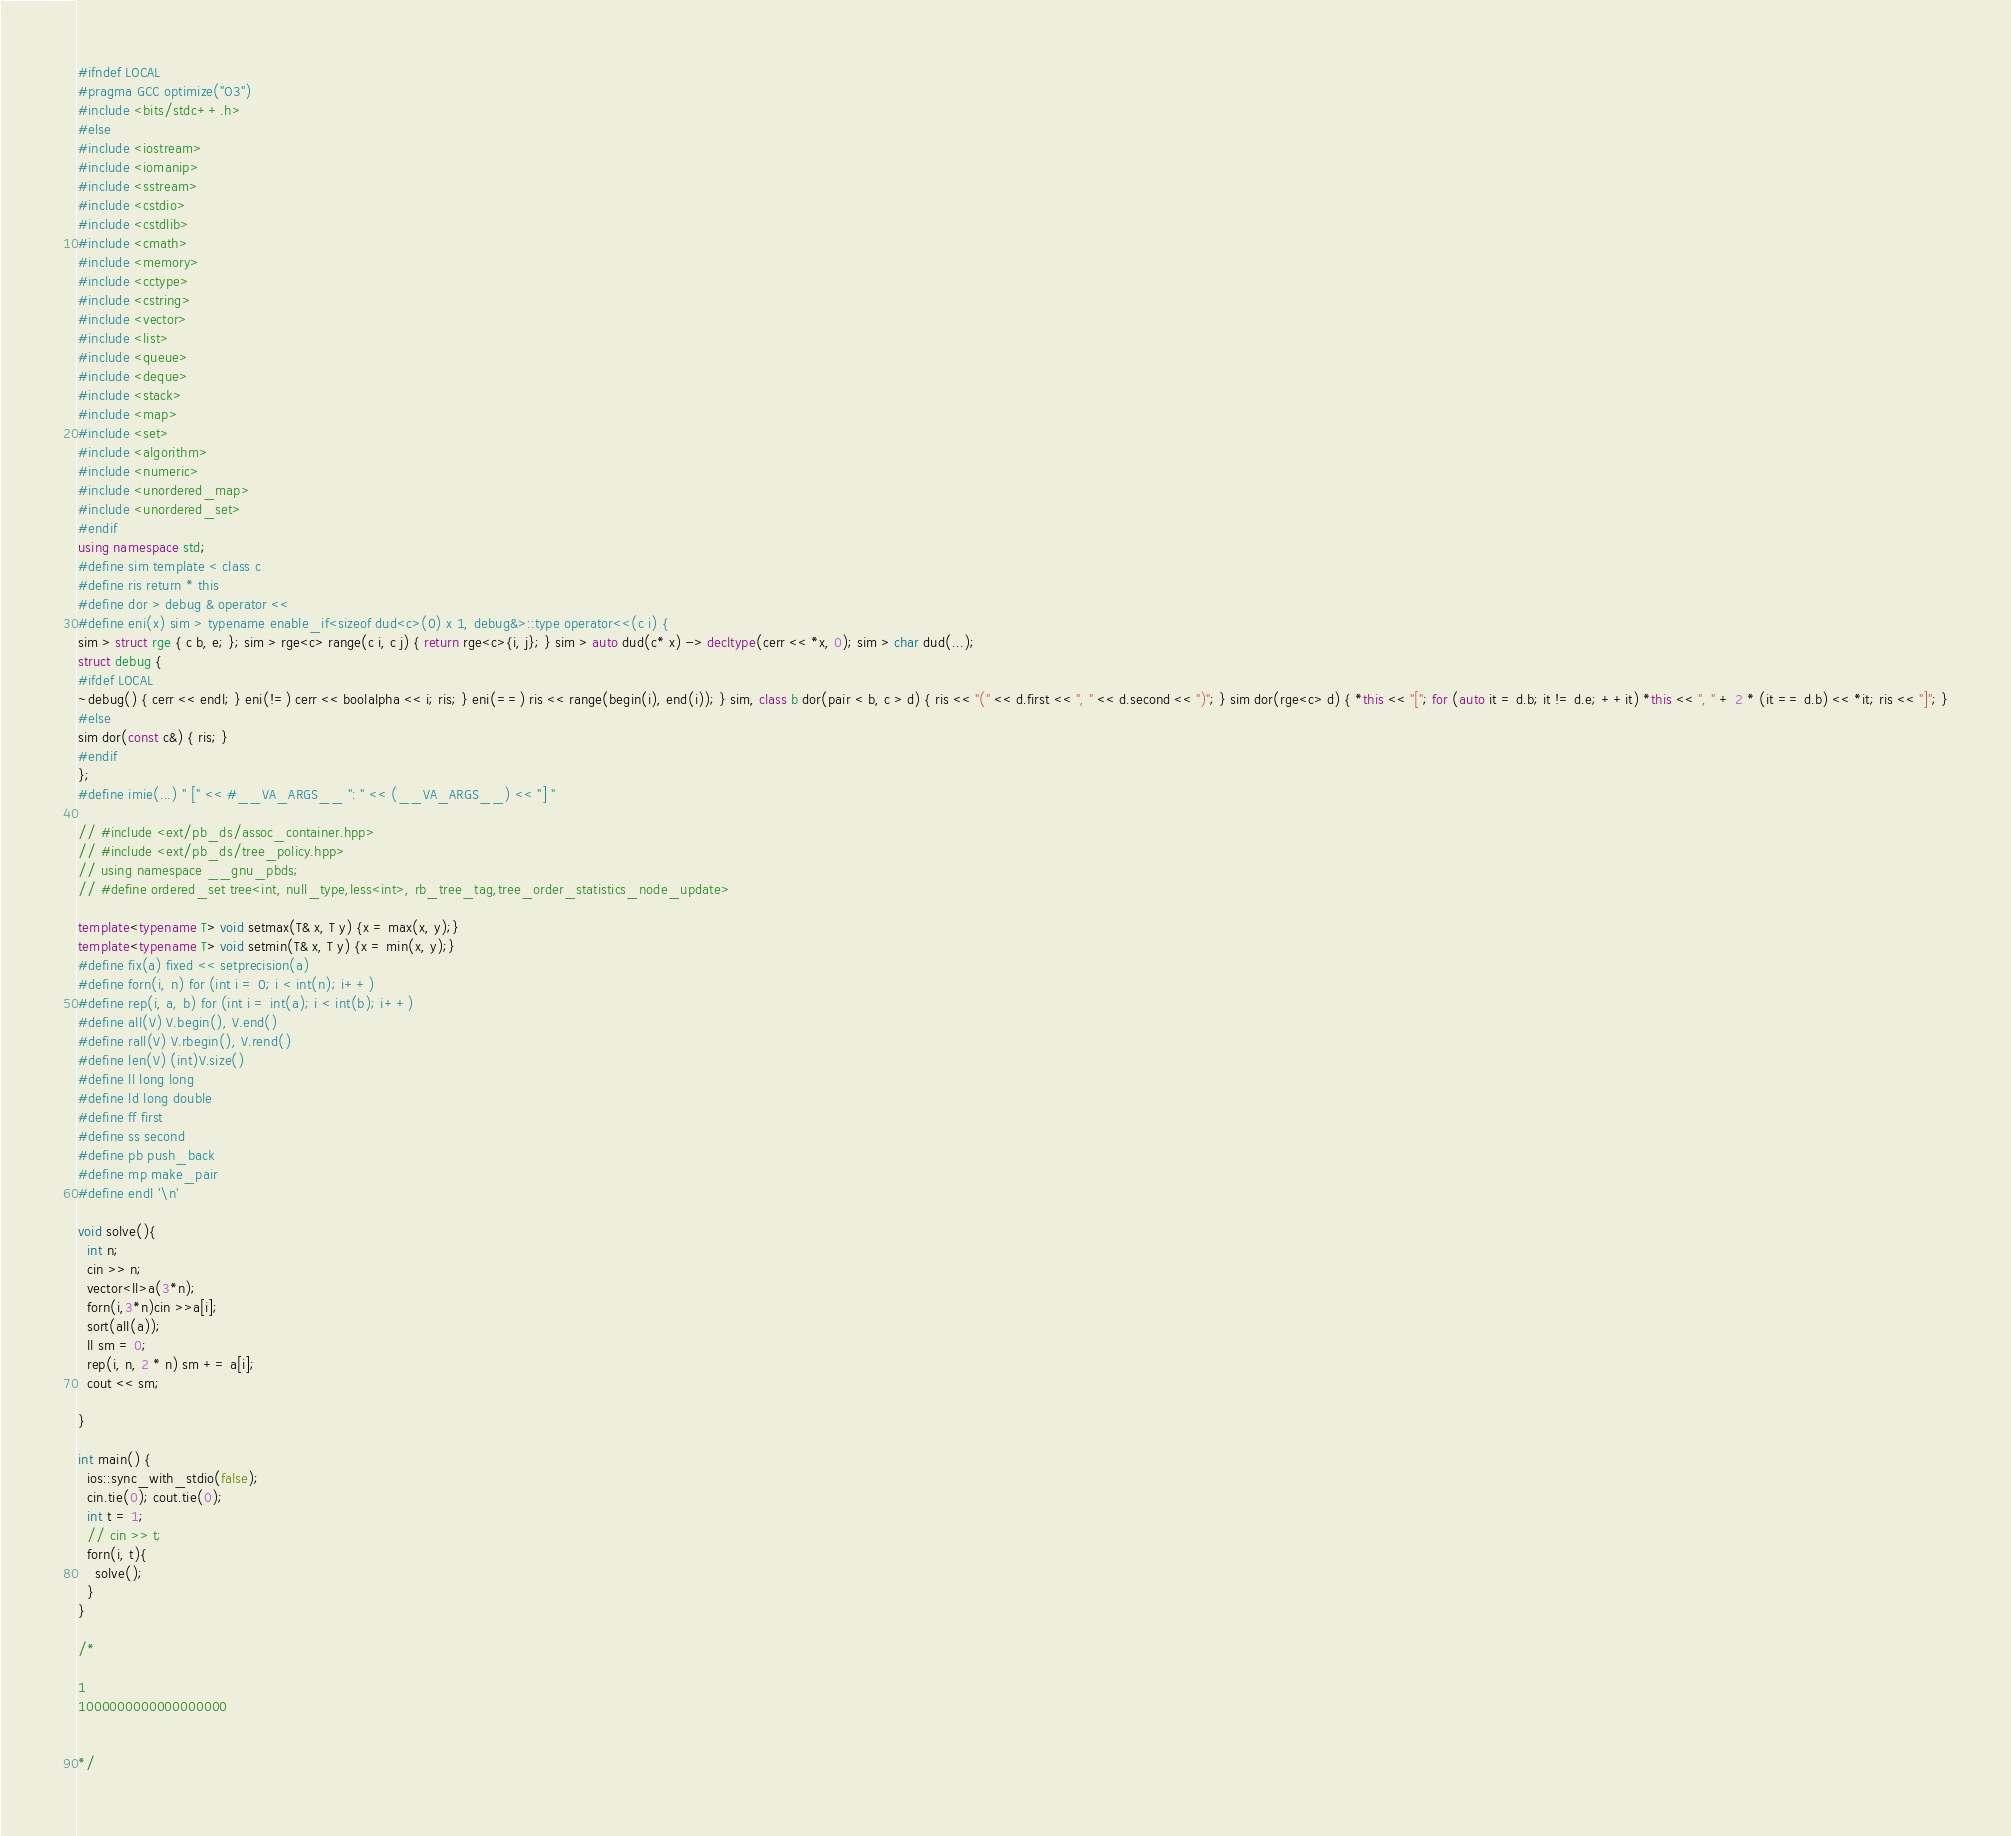<code> <loc_0><loc_0><loc_500><loc_500><_C++_>#ifndef LOCAL
#pragma GCC optimize("O3")
#include <bits/stdc++.h>
#else
#include <iostream>
#include <iomanip> 
#include <sstream>
#include <cstdio>
#include <cstdlib>
#include <cmath>
#include <memory>
#include <cctype>
#include <cstring>
#include <vector>
#include <list>
#include <queue>
#include <deque>
#include <stack>
#include <map>
#include <set>
#include <algorithm>
#include <numeric>
#include <unordered_map>
#include <unordered_set>
#endif
using namespace std;
#define sim template < class c
#define ris return * this
#define dor > debug & operator <<
#define eni(x) sim > typename enable_if<sizeof dud<c>(0) x 1, debug&>::type operator<<(c i) {
sim > struct rge { c b, e; }; sim > rge<c> range(c i, c j) { return rge<c>{i, j}; } sim > auto dud(c* x) -> decltype(cerr << *x, 0); sim > char dud(...);
struct debug {
#ifdef LOCAL
~debug() { cerr << endl; } eni(!=) cerr << boolalpha << i; ris; } eni(==) ris << range(begin(i), end(i)); } sim, class b dor(pair < b, c > d) { ris << "(" << d.first << ", " << d.second << ")"; } sim dor(rge<c> d) { *this << "["; for (auto it = d.b; it != d.e; ++it) *this << ", " + 2 * (it == d.b) << *it; ris << "]"; }
#else
sim dor(const c&) { ris; }
#endif
};
#define imie(...) " [" << #__VA_ARGS__ ": " << (__VA_ARGS__) << "] "

// #include <ext/pb_ds/assoc_container.hpp> 
// #include <ext/pb_ds/tree_policy.hpp> 
// using namespace __gnu_pbds; 
// #define ordered_set tree<int, null_type,less<int>, rb_tree_tag,tree_order_statistics_node_update> 

template<typename T> void setmax(T& x, T y) {x = max(x, y);}
template<typename T> void setmin(T& x, T y) {x = min(x, y);}
#define fix(a) fixed << setprecision(a)
#define forn(i, n) for (int i = 0; i < int(n); i++)
#define rep(i, a, b) for (int i = int(a); i < int(b); i++)
#define all(V) V.begin(), V.end()
#define rall(V) V.rbegin(), V.rend()
#define len(V) (int)V.size()
#define ll long long
#define ld long double
#define ff first
#define ss second
#define pb push_back
#define mp make_pair
#define endl '\n'

void solve(){
  int n;
  cin >> n;
  vector<ll>a(3*n);
  forn(i,3*n)cin >>a[i];
  sort(all(a));
  ll sm = 0;
  rep(i, n, 2 * n) sm += a[i];
  cout << sm;

}

int main() {
  ios::sync_with_stdio(false); 
  cin.tie(0); cout.tie(0);
  int t = 1;
  // cin >> t;
  forn(i, t){
    solve();
  }
}

/* 

1
1000000000000000000


*/</code> 